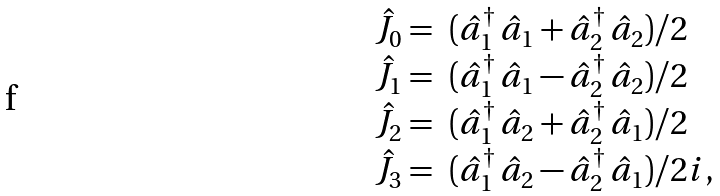<formula> <loc_0><loc_0><loc_500><loc_500>\begin{array} { r l } \hat { J } _ { 0 } = & ( \hat { a } _ { 1 } ^ { \dagger } \, \hat { a } _ { 1 } + \hat { a } _ { 2 } ^ { \dagger } \, \hat { a } _ { 2 } ) / 2 \\ \hat { J } _ { 1 } = & ( \hat { a } _ { 1 } ^ { \dagger } \, \hat { a } _ { 1 } - \hat { a } _ { 2 } ^ { \dagger } \, \hat { a } _ { 2 } ) / 2 \\ \hat { J } _ { 2 } = & ( \hat { a } _ { 1 } ^ { \dagger } \, \hat { a } _ { 2 } + \hat { a } _ { 2 } ^ { \dagger } \, \hat { a } _ { 1 } ) / 2 \\ \hat { J } _ { 3 } = & ( \hat { a } _ { 1 } ^ { \dagger } \, \hat { a } _ { 2 } - \hat { a } _ { 2 } ^ { \dagger } \, \hat { a } _ { 1 } ) / 2 i , \end{array}</formula> 